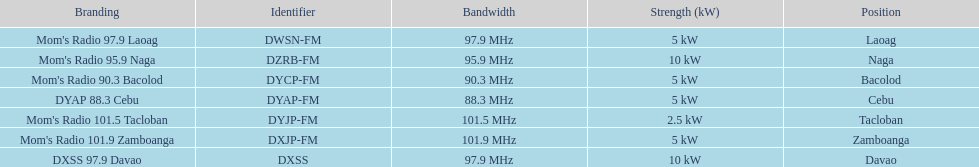What is the number of these stations broadcasting at a frequency of greater than 100 mhz? 2. 